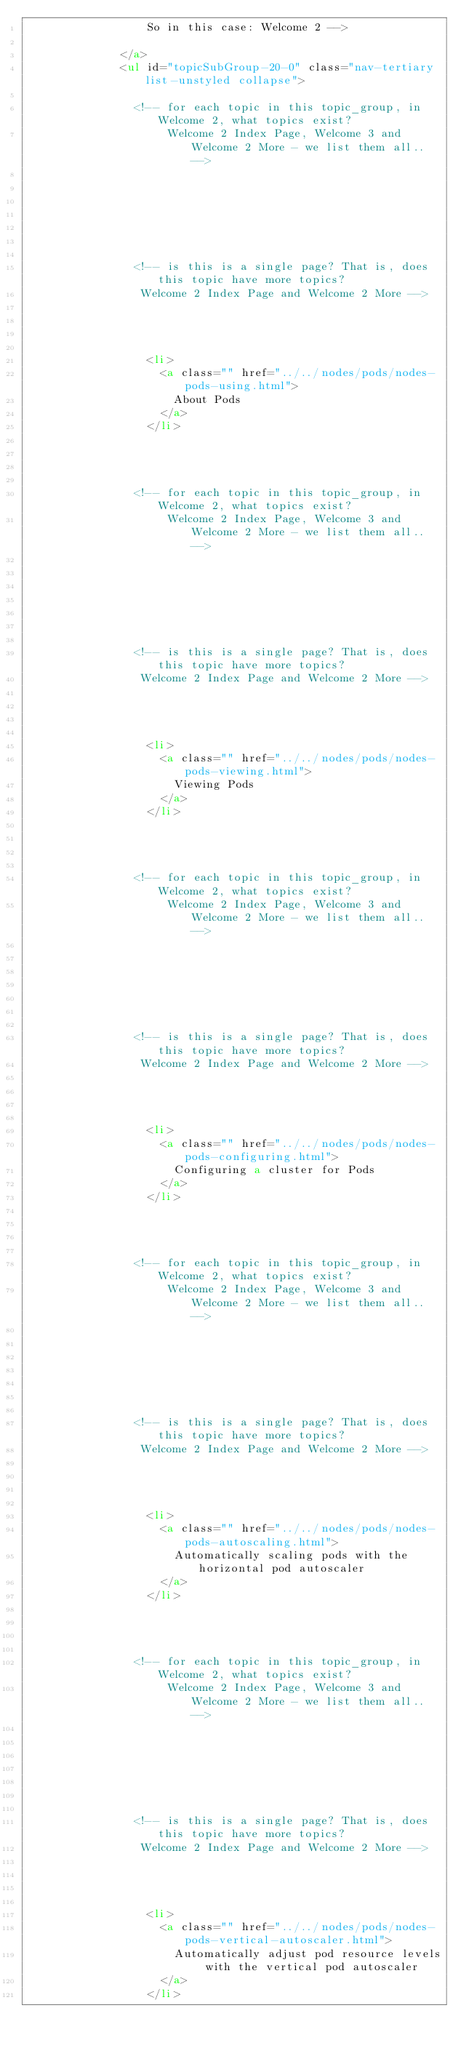<code> <loc_0><loc_0><loc_500><loc_500><_HTML_>                  So in this case: Welcome 2 -->

              </a>
              <ul id="topicSubGroup-20-0" class="nav-tertiary list-unstyled collapse">

                <!-- for each topic in this topic_group, in Welcome 2, what topics exist?
                     Welcome 2 Index Page, Welcome 3 and Welcome 2 More - we list them all.. -->

                
                
                
                
                

                <!-- is this is a single page? That is, does this topic have more topics?
                 Welcome 2 Index Page and Welcome 2 More -->




                  <li>
                    <a class="" href="../../nodes/pods/nodes-pods-using.html">
                      About Pods
                    </a>
                  </li>

                


                <!-- for each topic in this topic_group, in Welcome 2, what topics exist?
                     Welcome 2 Index Page, Welcome 3 and Welcome 2 More - we list them all.. -->

                
                
                
                
                

                <!-- is this is a single page? That is, does this topic have more topics?
                 Welcome 2 Index Page and Welcome 2 More -->




                  <li>
                    <a class="" href="../../nodes/pods/nodes-pods-viewing.html">
                      Viewing Pods
                    </a>
                  </li>

                


                <!-- for each topic in this topic_group, in Welcome 2, what topics exist?
                     Welcome 2 Index Page, Welcome 3 and Welcome 2 More - we list them all.. -->

                
                
                
                
                

                <!-- is this is a single page? That is, does this topic have more topics?
                 Welcome 2 Index Page and Welcome 2 More -->




                  <li>
                    <a class="" href="../../nodes/pods/nodes-pods-configuring.html">
                      Configuring a cluster for Pods
                    </a>
                  </li>

                


                <!-- for each topic in this topic_group, in Welcome 2, what topics exist?
                     Welcome 2 Index Page, Welcome 3 and Welcome 2 More - we list them all.. -->

                
                
                
                
                

                <!-- is this is a single page? That is, does this topic have more topics?
                 Welcome 2 Index Page and Welcome 2 More -->




                  <li>
                    <a class="" href="../../nodes/pods/nodes-pods-autoscaling.html">
                      Automatically scaling pods with the horizontal pod autoscaler
                    </a>
                  </li>

                


                <!-- for each topic in this topic_group, in Welcome 2, what topics exist?
                     Welcome 2 Index Page, Welcome 3 and Welcome 2 More - we list them all.. -->

                
                
                
                
                

                <!-- is this is a single page? That is, does this topic have more topics?
                 Welcome 2 Index Page and Welcome 2 More -->




                  <li>
                    <a class="" href="../../nodes/pods/nodes-pods-vertical-autoscaler.html">
                      Automatically adjust pod resource levels with the vertical pod autoscaler
                    </a>
                  </li>

                

</code> 